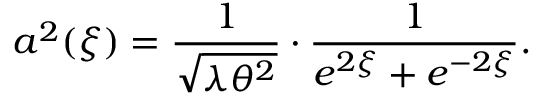Convert formula to latex. <formula><loc_0><loc_0><loc_500><loc_500>a ^ { 2 } ( \xi ) = \frac { 1 } { \sqrt { \lambda \theta ^ { 2 } } } \cdot \frac { 1 } { e ^ { 2 \xi } + e ^ { - 2 \xi } } .</formula> 